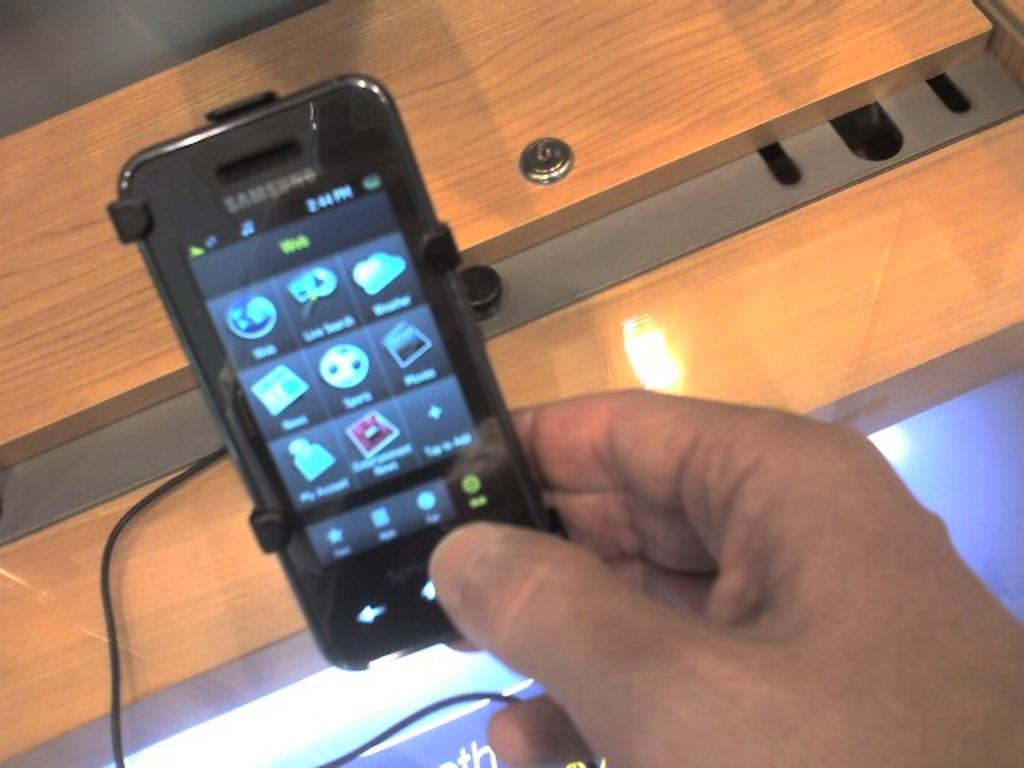<image>
Write a terse but informative summary of the picture. A Samsung cellphone held in someone's hand is connected to a charging station. 